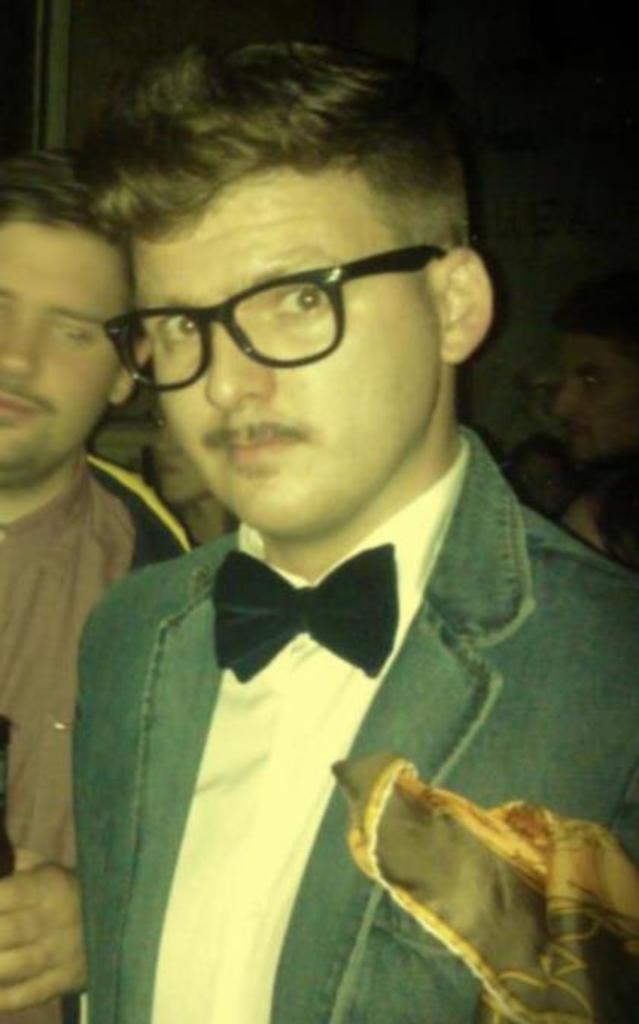In one or two sentences, can you explain what this image depicts? This picture seems to be clicked inside the room. In the center we can see the group of people seems to standing. In the foreground we can see a man wearing a blazer and seems to be standing and we can see some other items. 